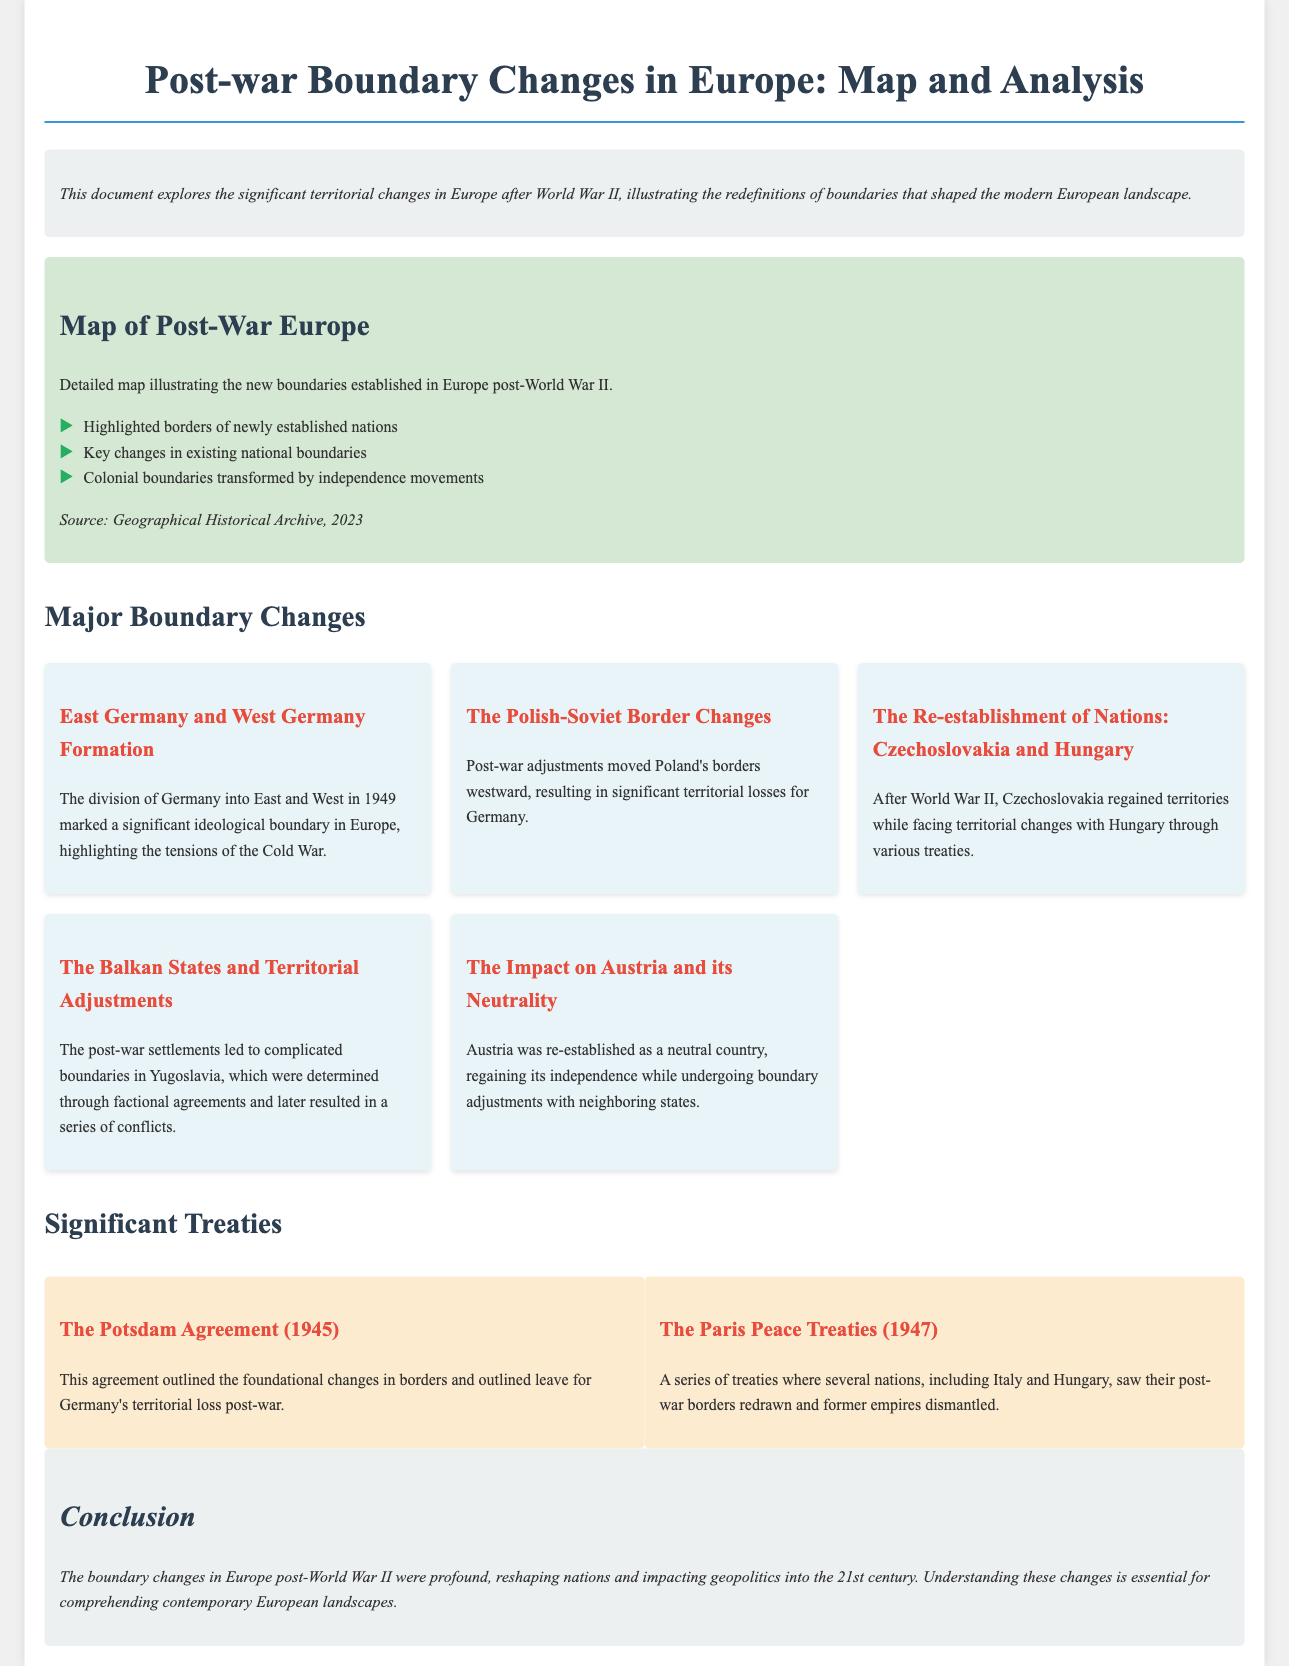What is the title of the document? The title of the document is provided in the header section.
Answer: Post-war Boundary Changes in Europe: Map and Analysis What year did the Potsdam Agreement take place? The year of the Potsdam Agreement is mentioned in the section discussing significant treaties.
Answer: 1945 Which two countries were formed after the division mentioned in the document? The formation of these countries is outlined in the section on major boundary changes.
Answer: East Germany and West Germany What agreement outlined Germany's territorial losses post-war? The agreement is specifically mentioned in the section discussing significant treaties.
Answer: The Potsdam Agreement What major change occurred to Poland's borders? This change is discussed in the major boundary changes section with specific geographic implications.
Answer: Poland's borders moved westward Which country was re-established as a neutral country after World War II? The document mentions this in the context of boundary adjustments.
Answer: Austria What treaties contributed to redrawing borders for Italy and Hungary? These treaties are highlighted in the section regarding significant treaties in the document.
Answer: The Paris Peace Treaties What was the impact of post-war settlements on Yugoslavia? The impact is described in the section regarding the Balkan States and their territorial adjustments.
Answer: Complicated boundaries leading to conflicts What type of map is provided in the document? The type of map is specified in the section regarding the map of post-war Europe.
Answer: Detailed map illustrating new boundaries 